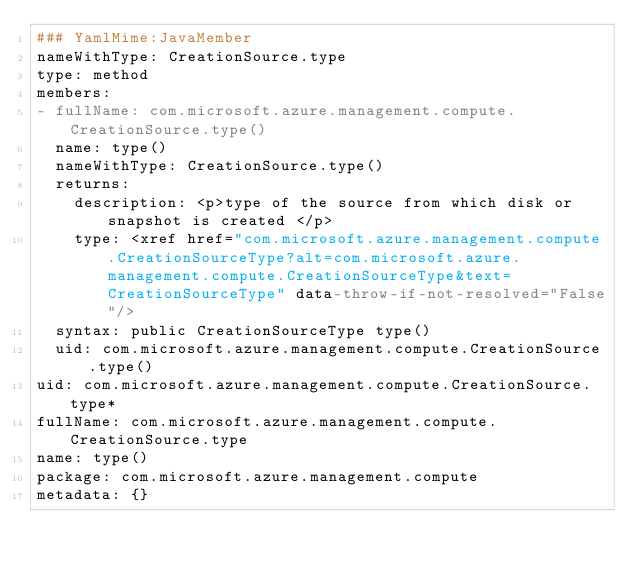Convert code to text. <code><loc_0><loc_0><loc_500><loc_500><_YAML_>### YamlMime:JavaMember
nameWithType: CreationSource.type
type: method
members:
- fullName: com.microsoft.azure.management.compute.CreationSource.type()
  name: type()
  nameWithType: CreationSource.type()
  returns:
    description: <p>type of the source from which disk or snapshot is created </p>
    type: <xref href="com.microsoft.azure.management.compute.CreationSourceType?alt=com.microsoft.azure.management.compute.CreationSourceType&text=CreationSourceType" data-throw-if-not-resolved="False"/>
  syntax: public CreationSourceType type()
  uid: com.microsoft.azure.management.compute.CreationSource.type()
uid: com.microsoft.azure.management.compute.CreationSource.type*
fullName: com.microsoft.azure.management.compute.CreationSource.type
name: type()
package: com.microsoft.azure.management.compute
metadata: {}
</code> 